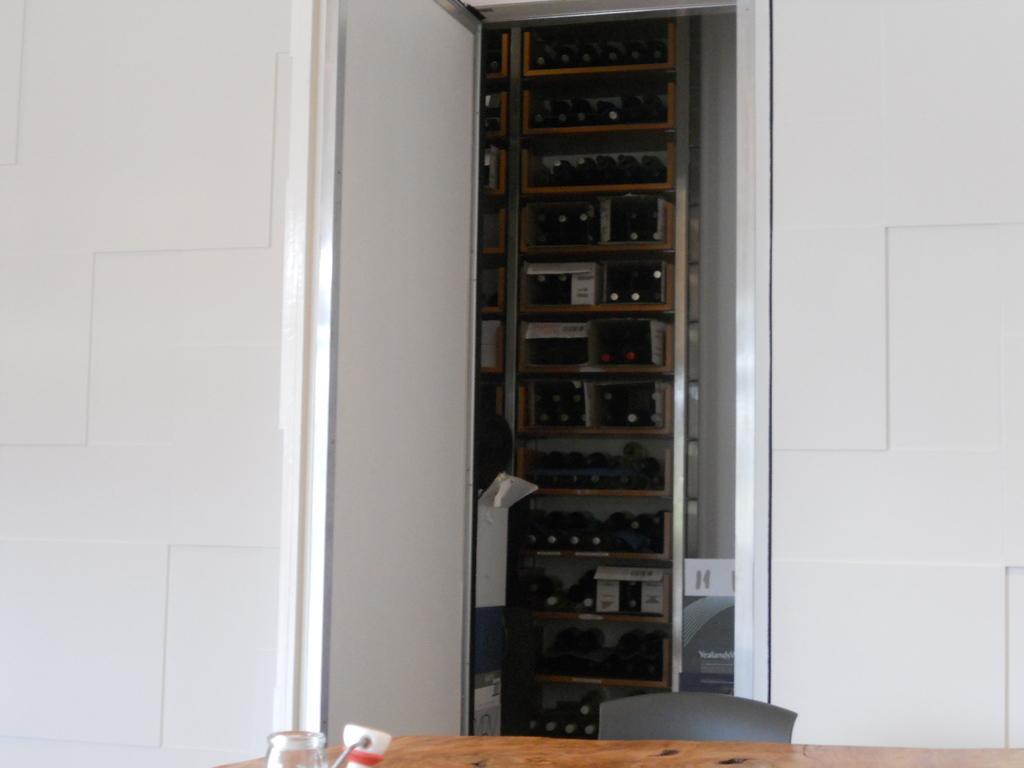Please provide a concise description of this image. In this image we can see the wooden table upon which we can see the glass and some object are placed. Here we can see the chair and the white color wheel. In the background, we can see many bottles are kept on the shelves. 